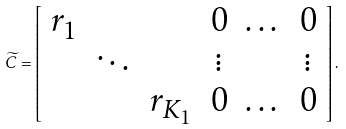Convert formula to latex. <formula><loc_0><loc_0><loc_500><loc_500>\widetilde { C } = \left [ \begin{array} { c c c c c c } r _ { 1 } & & & 0 & \dots & 0 \\ & \ddots & & \vdots & & \vdots \\ & & r _ { K _ { 1 } } & 0 & \dots & 0 \end{array} \right ] .</formula> 